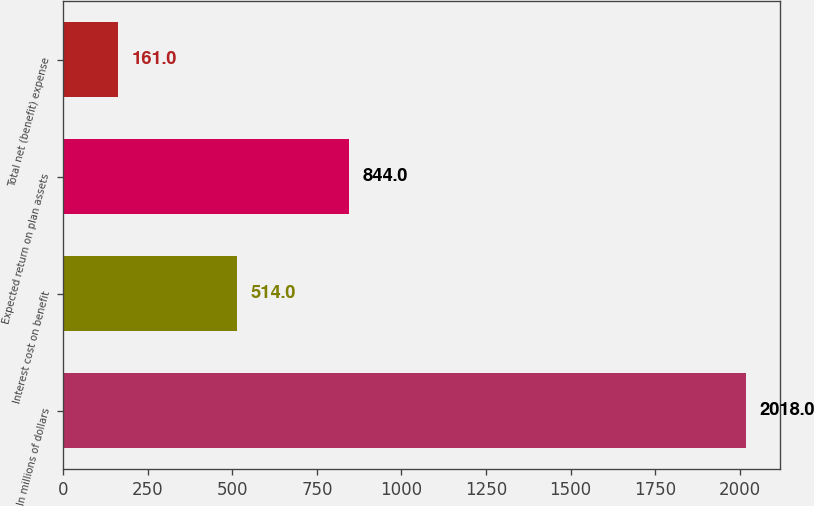Convert chart to OTSL. <chart><loc_0><loc_0><loc_500><loc_500><bar_chart><fcel>In millions of dollars<fcel>Interest cost on benefit<fcel>Expected return on plan assets<fcel>Total net (benefit) expense<nl><fcel>2018<fcel>514<fcel>844<fcel>161<nl></chart> 